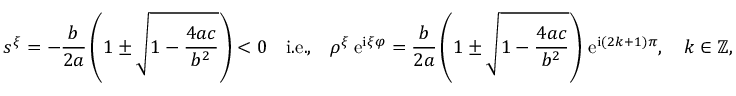<formula> <loc_0><loc_0><loc_500><loc_500>s ^ { \xi } = - \frac { b } { 2 a } \left ( 1 \pm \sqrt { 1 - \frac { 4 a c } { b ^ { 2 } } } \right ) < 0 \quad i . e . , \quad \rho ^ { \xi } \, e ^ { i \xi \varphi } = \frac { b } { 2 a } \left ( 1 \pm \sqrt { 1 - \frac { 4 a c } { b ^ { 2 } } } \right ) \, e ^ { i \left ( 2 k + 1 \right ) \pi } , \quad k \in \mathbb { Z } ,</formula> 